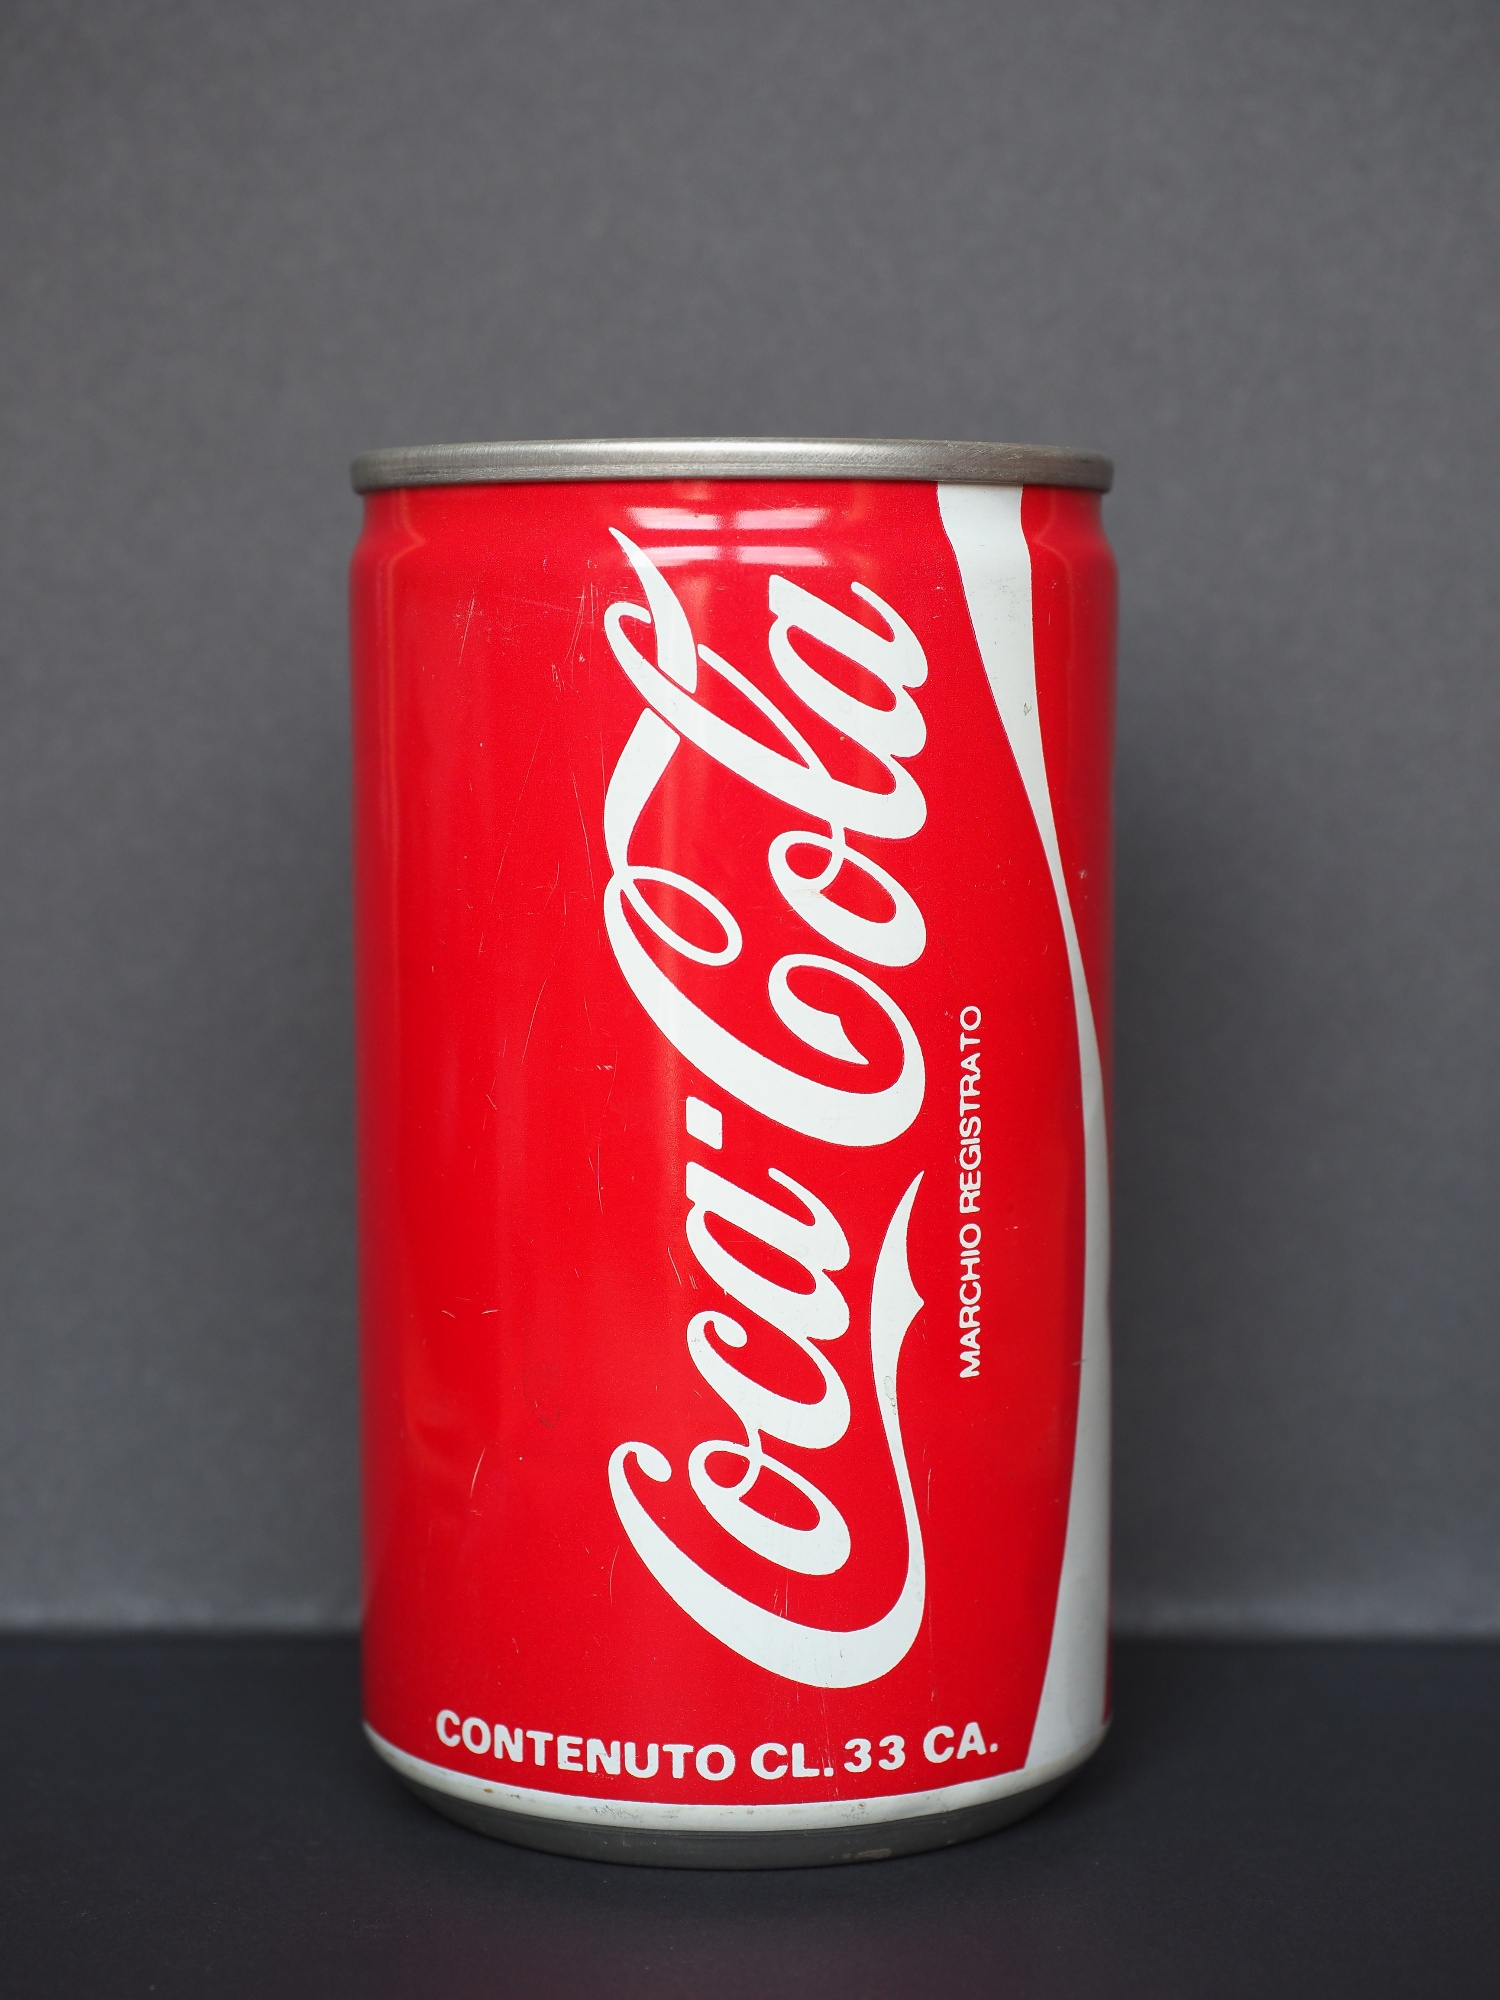Can you describe the scene in an imaginative way? Imagine a world where a lone Coca Cola can stands as a beacon of refreshment amidst a desert of gray. The vibrant red of the can boldly contrasts against the bleak, barren landscape, symbolizing hope and vitality. In this monochrome world, the can draws travelers from afar, its unmistakable icon promising a moment of joy and relief. The silver top sparkles like a distant star, guiding the way to those seeking respite from their gray surroundings. This singular can, with its familiar logo and Italian inscriptions, becomes a treasure, a cherished relic in a land devoid of color. 